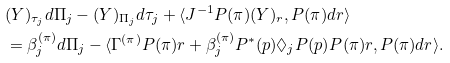<formula> <loc_0><loc_0><loc_500><loc_500>& ( Y ) _ { \tau _ { j } } d \Pi _ { j } - ( Y ) _ { \Pi _ { j } } d \tau _ { j } + \langle J ^ { - 1 } P ( \pi ) ( Y ) _ { r } , P ( \pi ) d r \rangle \\ & = \beta _ { j } ^ { ( \pi ) } d \Pi _ { j } - \langle \Gamma ^ { ( \pi ) } P ( \pi ) r + \beta _ { j } ^ { ( \pi ) } P ^ { * } ( p ) \Diamond _ { j } P ( p ) P ( \pi ) r , P ( \pi ) d r \rangle .</formula> 